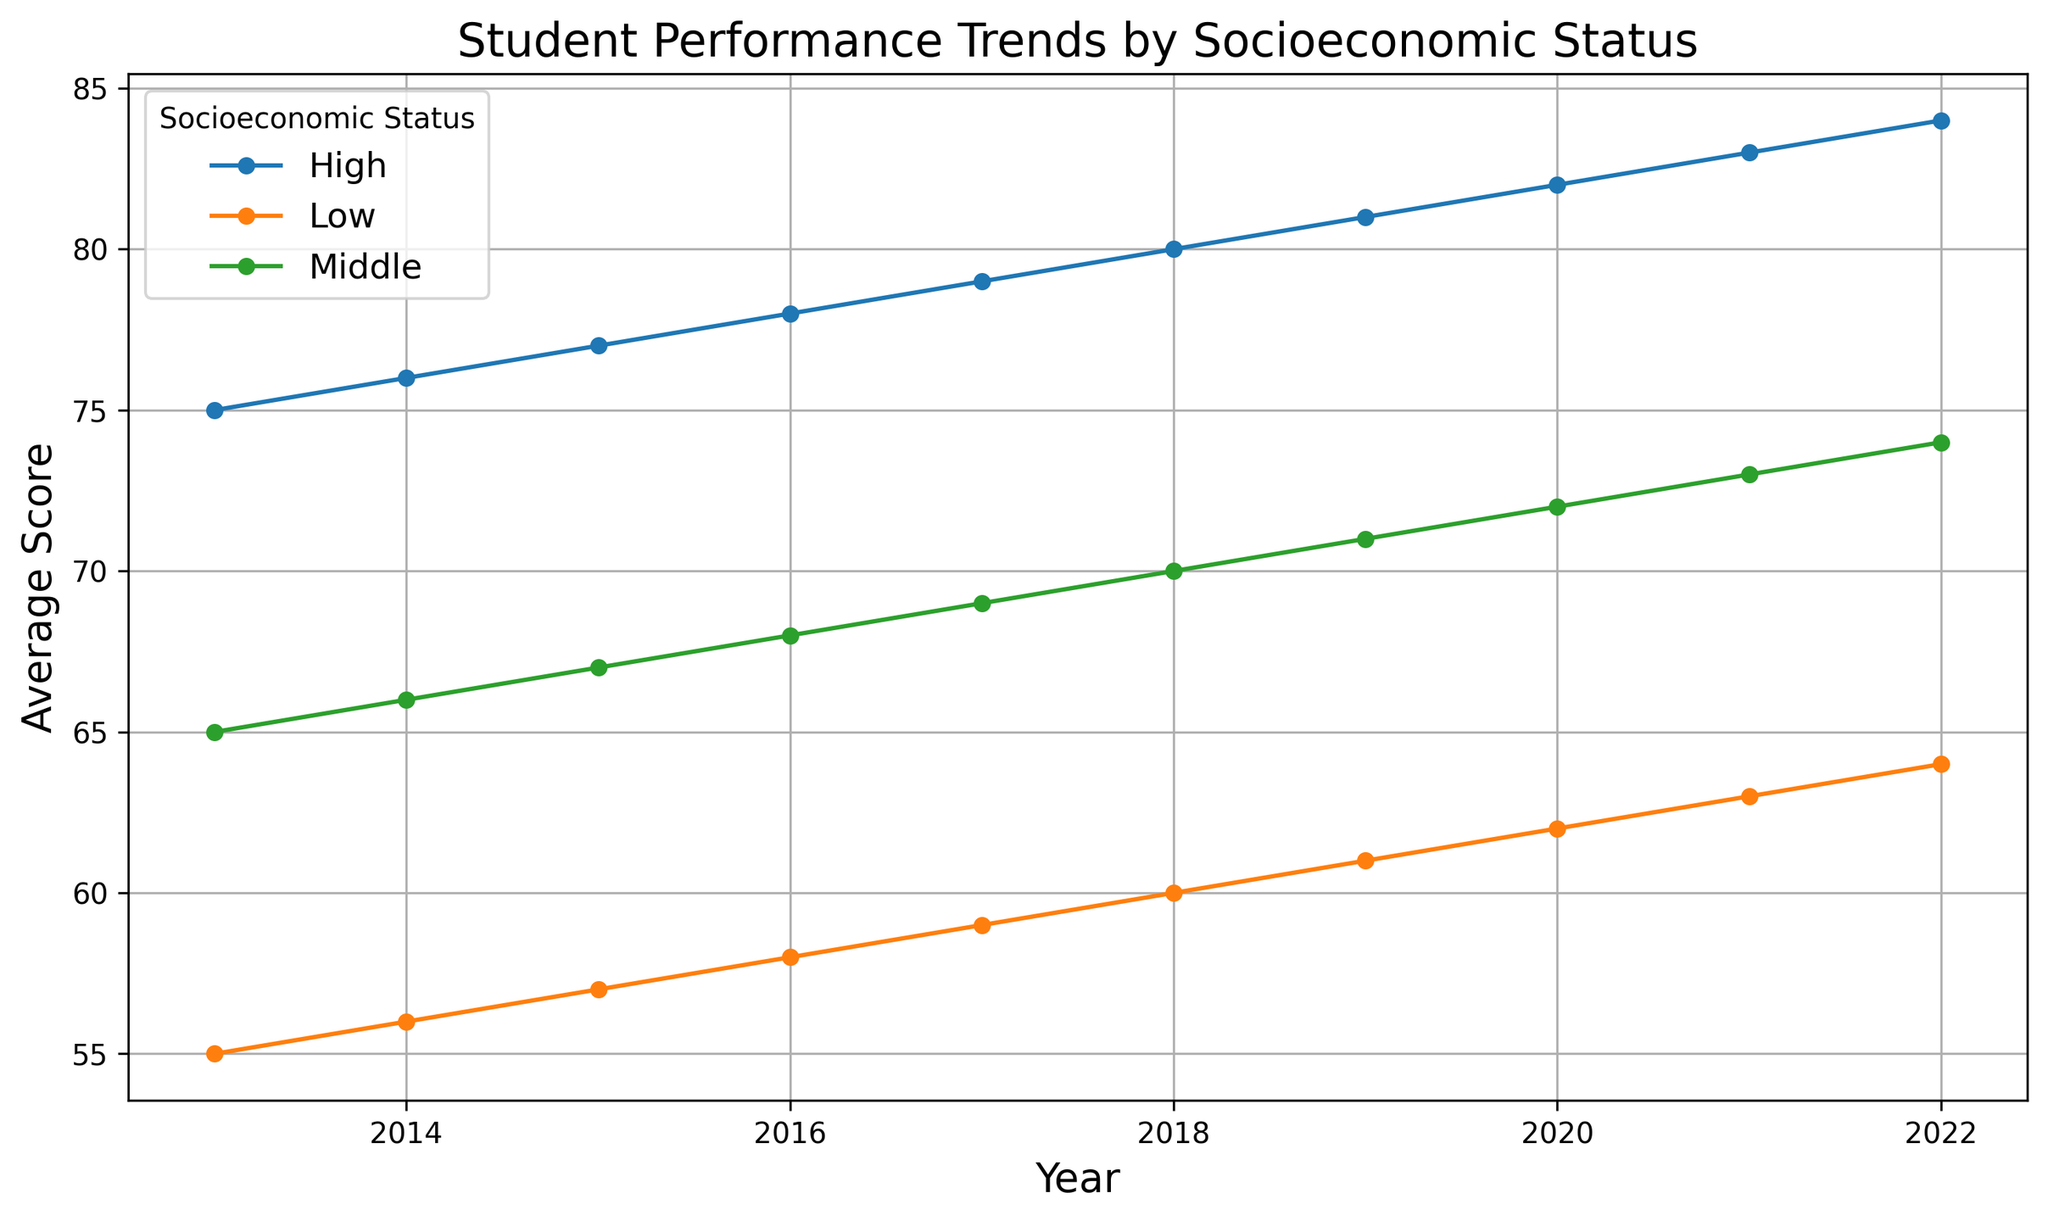What's the overall trend in student performance for all socioeconomic statuses from 2013 to 2022? From 2013 to 2022, the average scores for students in all socioeconomic statuses have steadily increased each year.
Answer: Increasing How much did the average score for students from low socioeconomic status increase from 2013 to 2022? In 2013, the score was 55. By 2022, it rose to 64. The increase is 64 - 55 = 9 points.
Answer: 9 points Which socioeconomic status group showed the highest average score in 2021? In 2021, the high socioeconomic status group had the highest average score of 83.
Answer: High By how many points did the average score for middle socioeconomic status students change from 2015 to 2018? In 2015, the score was 67. In 2018, it was 70. The change is 70 - 67 = 3 points.
Answer: 3 points What is the difference in the average scores of low socioeconomic status students in 2013 and high socioeconomic status students in 2022? The average score of low socioeconomic status students in 2013 was 55, and for high socioeconomic status students in 2022, it was 84. The difference is 84 - 55 = 29 points.
Answer: 29 points How does the overall trend of high socioeconomic status students’ performance compare to that of low socioeconomic status students over the decade? Both low and high socioeconomic status students show a consistent upward trend in performance from 2013 to 2022, but the high socioeconomic status students always score higher and have the same rate of increase each year.
Answer: Both increasing equally What is the yearly average increase in the average score for middle socioeconomic status students from 2013 to 2022? Initial score in 2013 was 65 and final in 2022 was 74. The total increase is 74 - 65 = 9 points over 9 years. The average yearly increase is 9 / 9 = 1 point per year.
Answer: 1 point per year Between which consecutive years did the average score of high socioeconomic status students reach 80? The average score for high socioeconomic status students is 79 in 2017 and 80 in 2018. Hence, the score reached 80 between these two years.
Answer: 2017-2018 